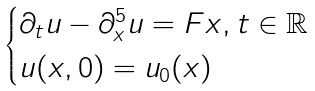<formula> <loc_0><loc_0><loc_500><loc_500>\begin{cases} \partial _ { t } u - \partial _ { x } ^ { 5 } u = F x , t \in \mathbb { R } \\ u ( x , 0 ) = u _ { 0 } ( x ) \end{cases}</formula> 